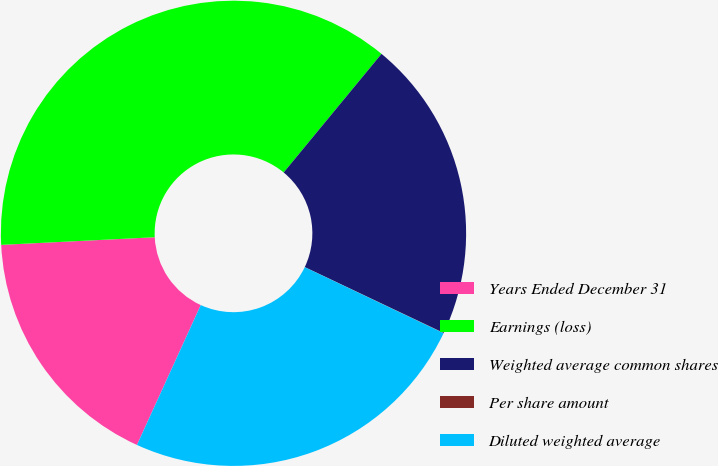Convert chart. <chart><loc_0><loc_0><loc_500><loc_500><pie_chart><fcel>Years Ended December 31<fcel>Earnings (loss)<fcel>Weighted average common shares<fcel>Per share amount<fcel>Diluted weighted average<nl><fcel>17.4%<fcel>36.77%<fcel>21.07%<fcel>0.02%<fcel>24.75%<nl></chart> 